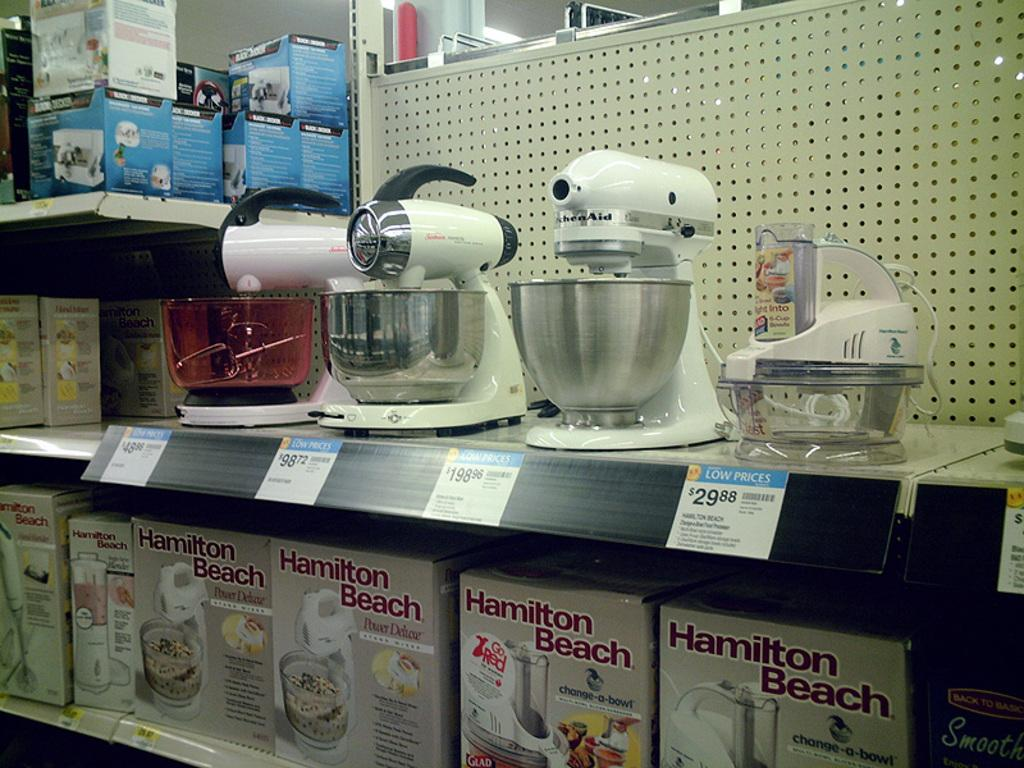<image>
Share a concise interpretation of the image provided. many stand mixers are sitting above the hamilton beach display 